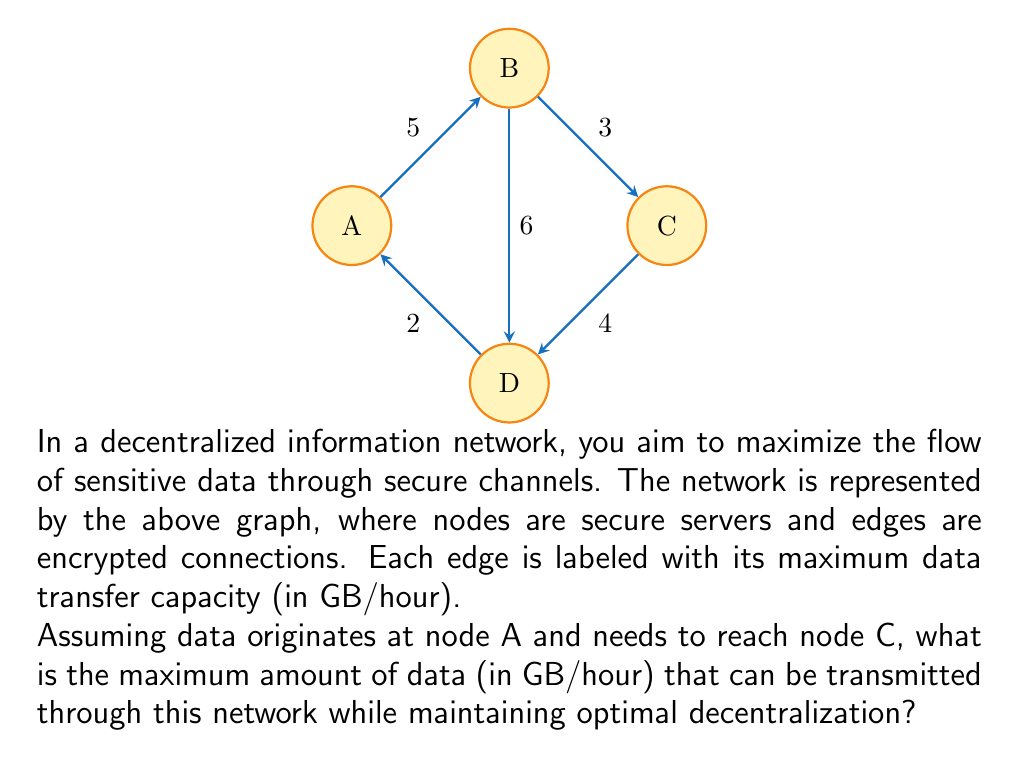What is the answer to this math problem? To solve this problem, we need to use the max-flow min-cut theorem from network flow theory. Here's a step-by-step approach:

1) First, identify all possible paths from A to C:
   Path 1: A -> B -> C
   Path 2: A -> D -> C
   Path 3: A -> B -> D -> C
   Path 4: A -> D -> B -> C

2) Now, we need to find the bottleneck (minimum capacity) for each path:
   Path 1: min(5, 3) = 3
   Path 2: min(2, 4) = 2
   Path 3: min(5, 6, 4) = 4
   Path 4: min(2, 6, 3) = 2

3) The maximum flow will be the sum of flows through all these paths, but we need to be careful not to exceed the capacity of any edge.

4) Start with the path with the highest capacity: Path 3 with 4 GB/hour.

5) After using Path 3, the remaining capacities are:
   A -> B: 1 GB/hour
   A -> D: 0 GB/hour (fully utilized)
   B -> C: 0 GB/hour (fully utilized)
   B -> D: 2 GB/hour
   D -> C: 0 GB/hour (fully utilized)

6) We can now only use Path 1 with its remaining capacity of 1 GB/hour.

7) Therefore, the maximum flow is 4 + 1 = 5 GB/hour.

This solution ensures optimal decentralization by utilizing multiple paths and not relying solely on the most direct route.
Answer: 5 GB/hour 